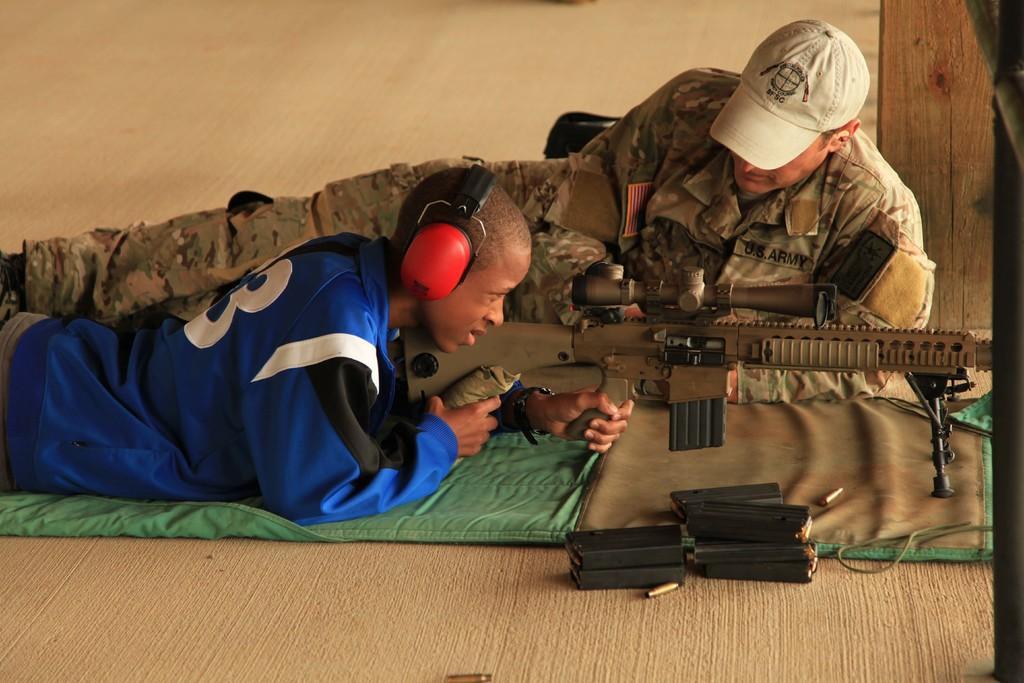Describe this image in one or two sentences. In this image we can see two persons lying on the floor. One person wearing blue jacket and headphones is holding a gun in his hand. One person is wearing a military uniform and a cap. In the foreground we can see some boxes. 